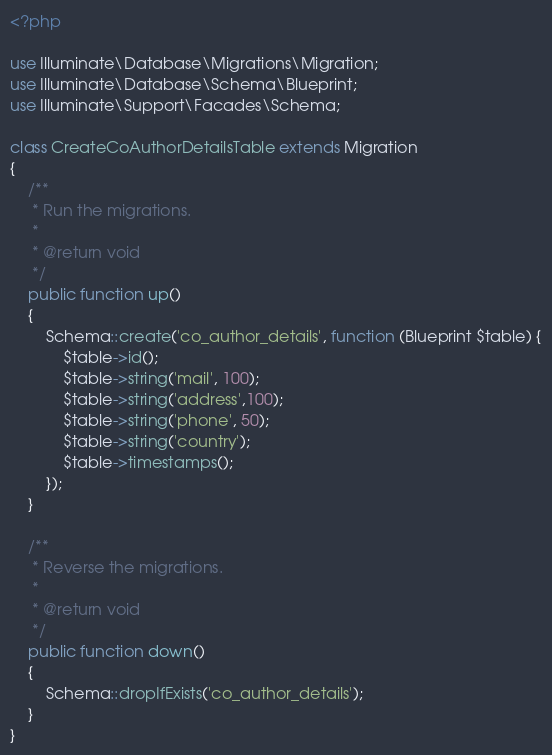Convert code to text. <code><loc_0><loc_0><loc_500><loc_500><_PHP_><?php

use Illuminate\Database\Migrations\Migration;
use Illuminate\Database\Schema\Blueprint;
use Illuminate\Support\Facades\Schema;

class CreateCoAuthorDetailsTable extends Migration
{
    /**
     * Run the migrations.
     *
     * @return void
     */
    public function up()
    {
        Schema::create('co_author_details', function (Blueprint $table) {
            $table->id();
            $table->string('mail', 100);
            $table->string('address',100);
            $table->string('phone', 50);
            $table->string('country');
            $table->timestamps();
        });
    }

    /**
     * Reverse the migrations.
     *
     * @return void
     */
    public function down()
    {
        Schema::dropIfExists('co_author_details');
    }
}
</code> 